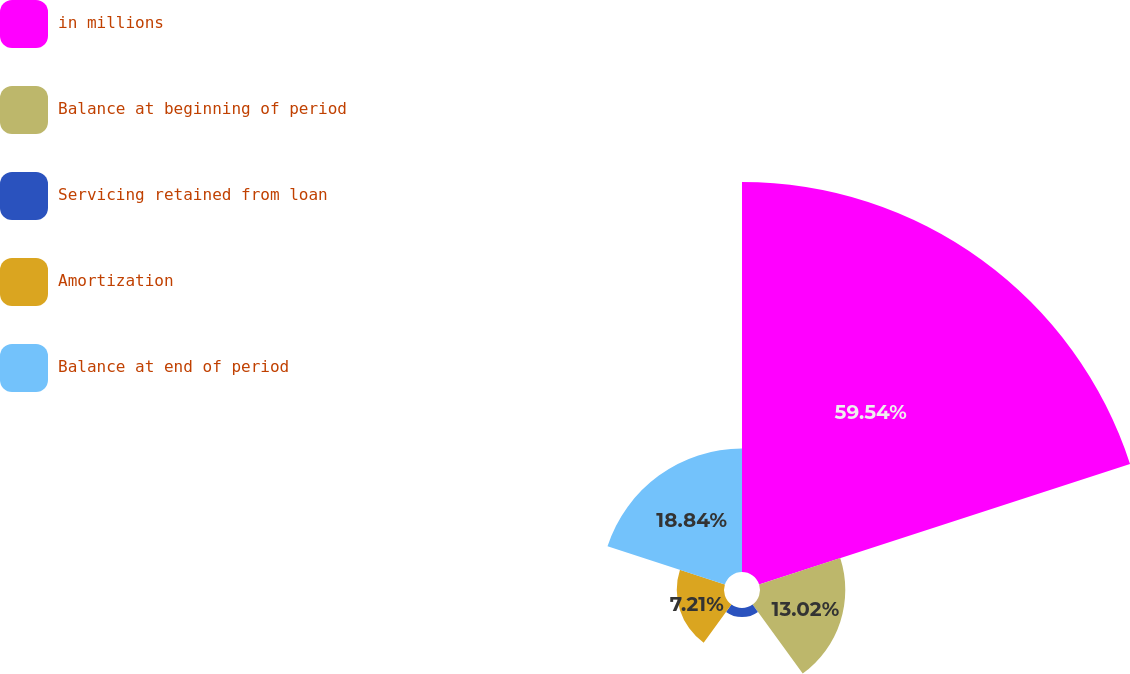Convert chart. <chart><loc_0><loc_0><loc_500><loc_500><pie_chart><fcel>in millions<fcel>Balance at beginning of period<fcel>Servicing retained from loan<fcel>Amortization<fcel>Balance at end of period<nl><fcel>59.54%<fcel>13.02%<fcel>1.39%<fcel>7.21%<fcel>18.84%<nl></chart> 